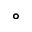<formula> <loc_0><loc_0><loc_500><loc_500>^ { \circ }</formula> 